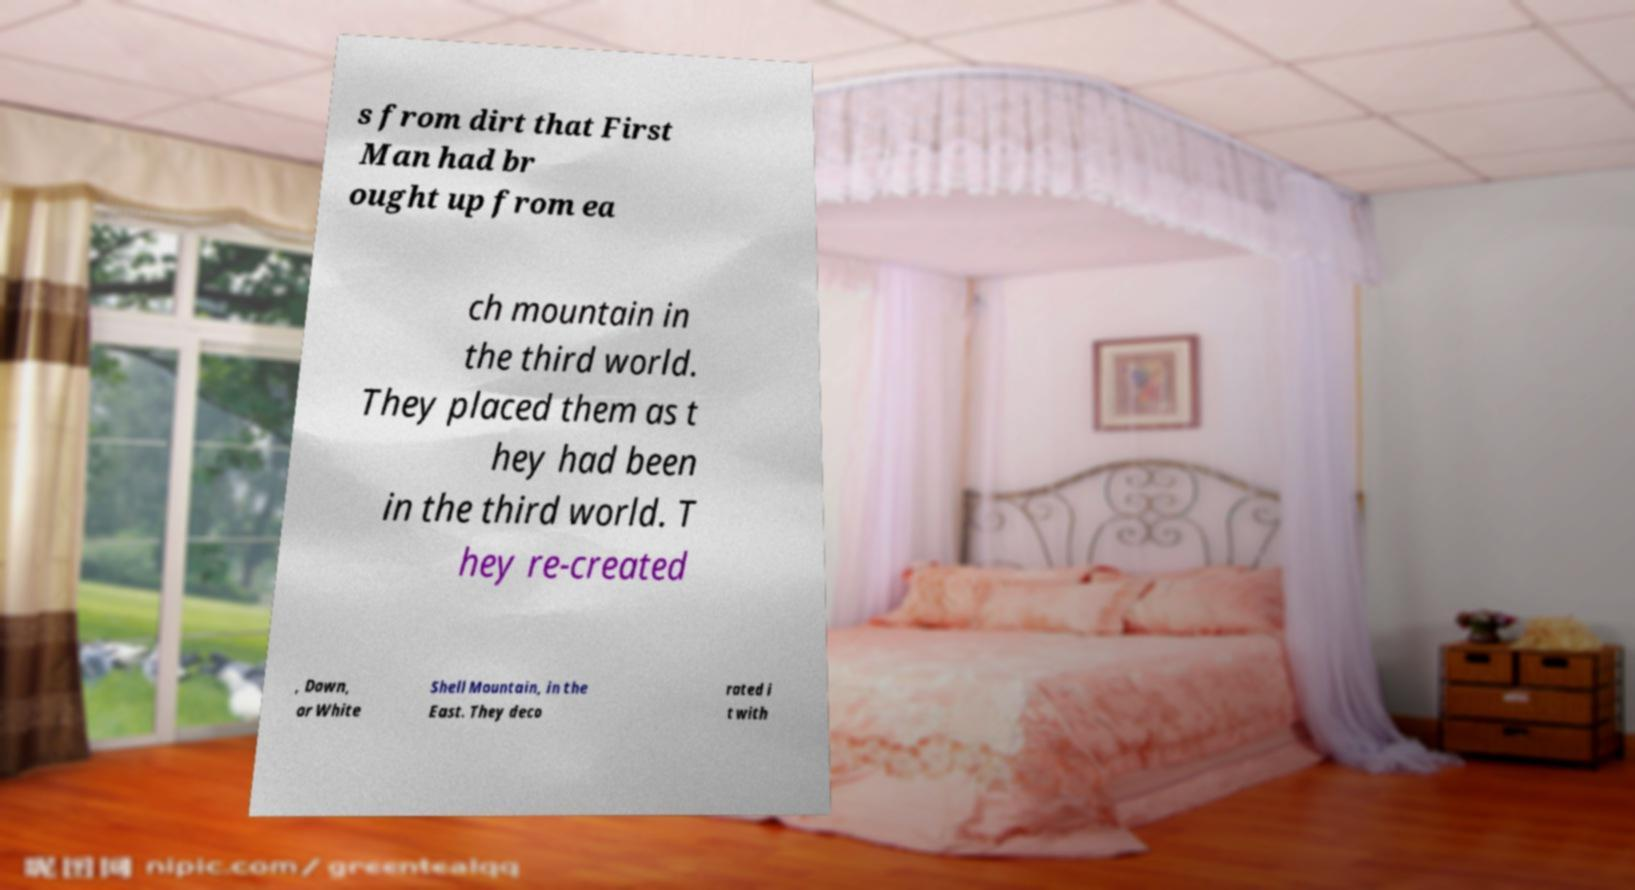Can you accurately transcribe the text from the provided image for me? s from dirt that First Man had br ought up from ea ch mountain in the third world. They placed them as t hey had been in the third world. T hey re-created , Dawn, or White Shell Mountain, in the East. They deco rated i t with 